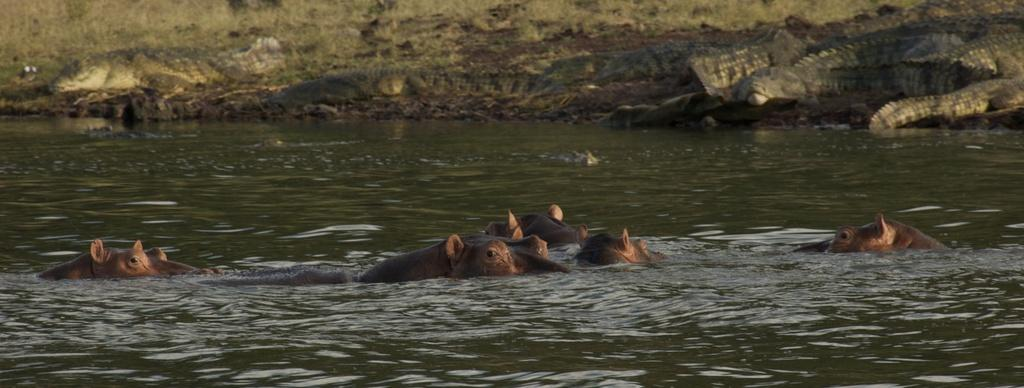What type of animals can be seen in the image? There are animals in the water. What other animals can be seen in the background of the image? There are crocodiles in the background of the image. What type of ornament is hanging from the tray in the image? There is no tray or ornament present in the image. 